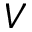Convert formula to latex. <formula><loc_0><loc_0><loc_500><loc_500>V</formula> 